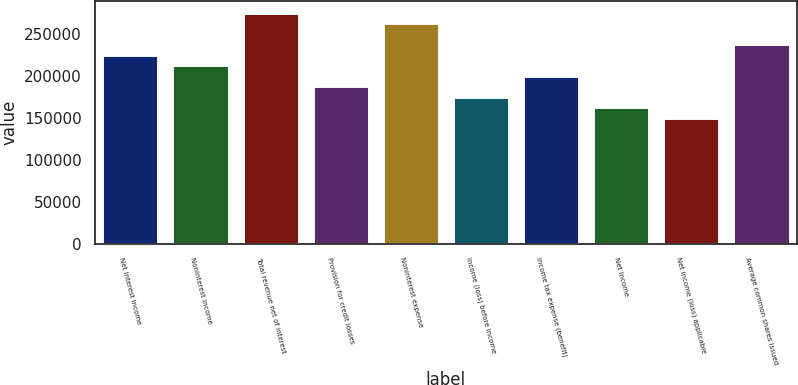<chart> <loc_0><loc_0><loc_500><loc_500><bar_chart><fcel>Net interest income<fcel>Noninterest income<fcel>Total revenue net of interest<fcel>Provision for credit losses<fcel>Noninterest expense<fcel>Income (loss) before income<fcel>Income tax expense (benefit)<fcel>Net income<fcel>Net income (loss) applicable<fcel>Average common shares issued<nl><fcel>225245<fcel>212731<fcel>275299<fcel>187704<fcel>262786<fcel>175190<fcel>200218<fcel>162677<fcel>150163<fcel>237758<nl></chart> 